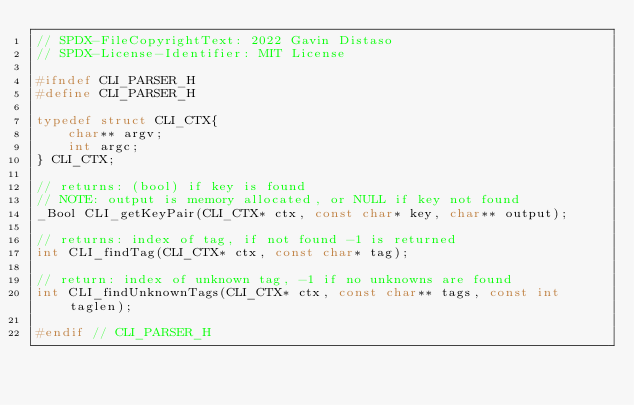<code> <loc_0><loc_0><loc_500><loc_500><_C_>// SPDX-FileCopyrightText: 2022 Gavin Distaso
// SPDX-License-Identifier: MIT License

#ifndef CLI_PARSER_H
#define CLI_PARSER_H

typedef struct CLI_CTX{
    char** argv;
    int argc;
} CLI_CTX;

// returns: (bool) if key is found
// NOTE: output is memory allocated, or NULL if key not found
_Bool CLI_getKeyPair(CLI_CTX* ctx, const char* key, char** output);

// returns: index of tag, if not found -1 is returned
int CLI_findTag(CLI_CTX* ctx, const char* tag);

// return: index of unknown tag, -1 if no unknowns are found
int CLI_findUnknownTags(CLI_CTX* ctx, const char** tags, const int taglen);

#endif // CLI_PARSER_H</code> 